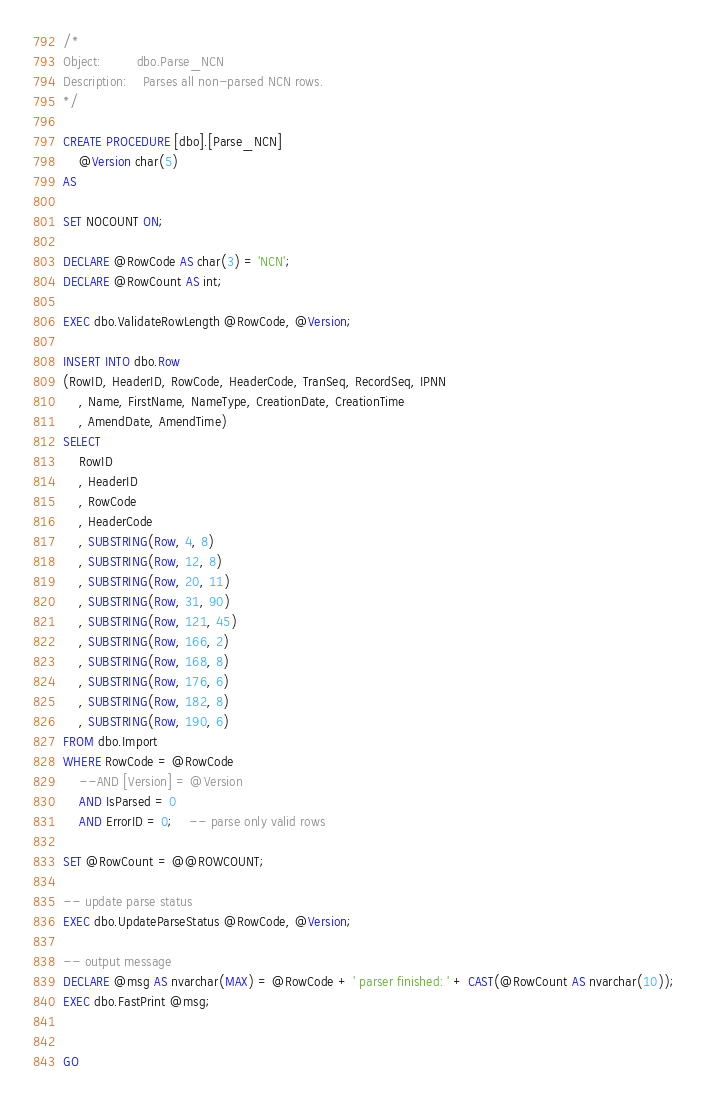Convert code to text. <code><loc_0><loc_0><loc_500><loc_500><_SQL_>
/*
Object:			dbo.Parse_NCN
Description:	Parses all non-parsed NCN rows.
*/

CREATE PROCEDURE [dbo].[Parse_NCN]
	@Version char(5)
AS

SET NOCOUNT ON;

DECLARE @RowCode AS char(3) = 'NCN';
DECLARE @RowCount AS int;

EXEC dbo.ValidateRowLength @RowCode, @Version;

INSERT INTO dbo.Row
(RowID, HeaderID, RowCode, HeaderCode, TranSeq, RecordSeq, IPNN
	, Name, FirstName, NameType, CreationDate, CreationTime
	, AmendDate, AmendTime)
SELECT 
	RowID
	, HeaderID
	, RowCode
	, HeaderCode
	, SUBSTRING(Row, 4, 8)
	, SUBSTRING(Row, 12, 8)
	, SUBSTRING(Row, 20, 11)
	, SUBSTRING(Row, 31, 90)
	, SUBSTRING(Row, 121, 45)
	, SUBSTRING(Row, 166, 2)
	, SUBSTRING(Row, 168, 8)
	, SUBSTRING(Row, 176, 6)
	, SUBSTRING(Row, 182, 8)
	, SUBSTRING(Row, 190, 6)	
FROM dbo.Import
WHERE RowCode = @RowCode
	--AND [Version] = @Version
	AND IsParsed = 0
	AND ErrorID = 0;	-- parse only valid rows

SET @RowCount = @@ROWCOUNT;

-- update parse status
EXEC dbo.UpdateParseStatus @RowCode, @Version;

-- output message
DECLARE @msg AS nvarchar(MAX) = @RowCode + ' parser finished: ' + CAST(@RowCount AS nvarchar(10));
EXEC dbo.FastPrint @msg;


GO


</code> 